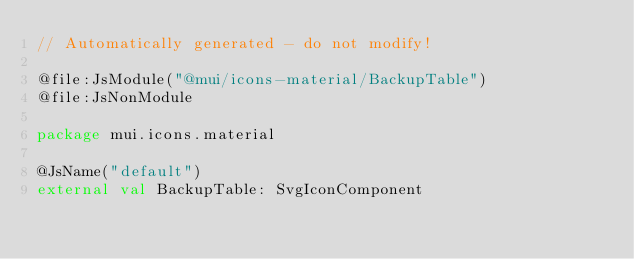Convert code to text. <code><loc_0><loc_0><loc_500><loc_500><_Kotlin_>// Automatically generated - do not modify!

@file:JsModule("@mui/icons-material/BackupTable")
@file:JsNonModule

package mui.icons.material

@JsName("default")
external val BackupTable: SvgIconComponent
</code> 